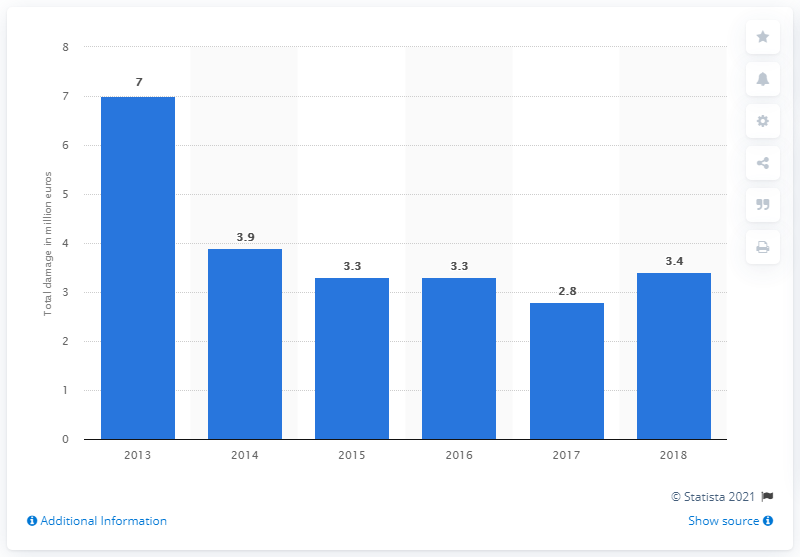Point out several critical features in this image. The total damage caused by credit card fraud in the Netherlands in 2018 was 3.4 billion euros. 